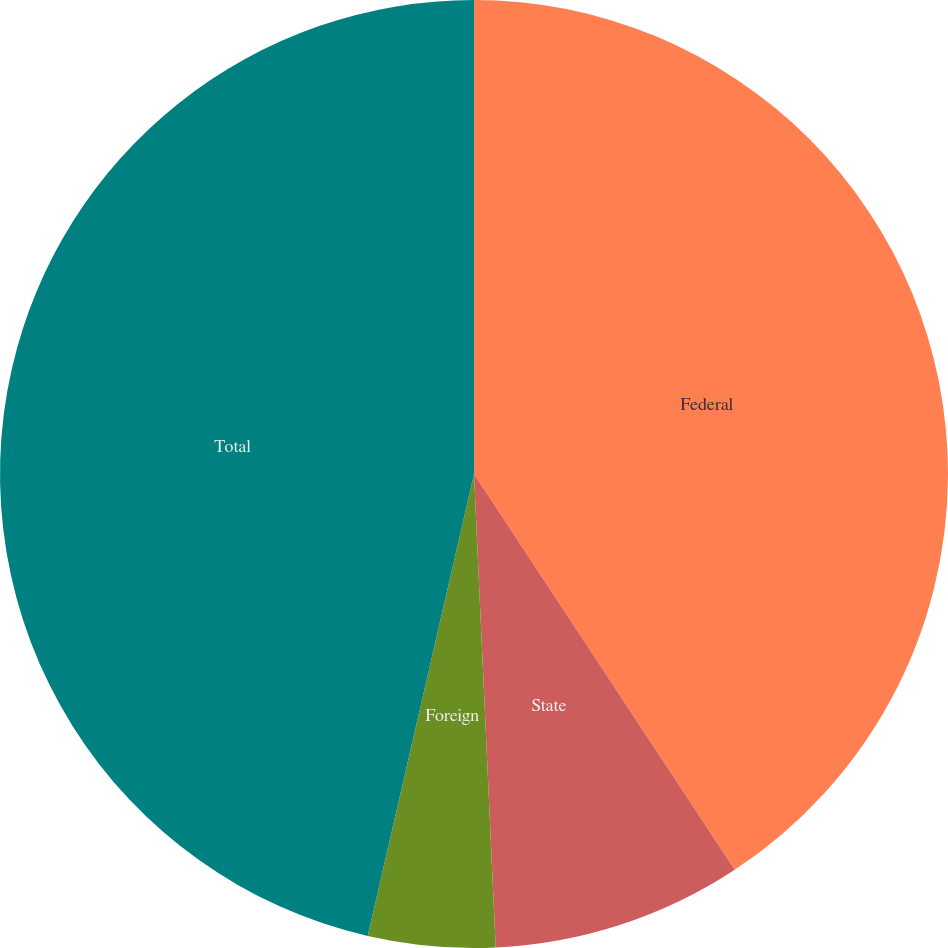Convert chart to OTSL. <chart><loc_0><loc_0><loc_500><loc_500><pie_chart><fcel>Federal<fcel>State<fcel>Foreign<fcel>Total<nl><fcel>40.73%<fcel>8.54%<fcel>4.33%<fcel>46.4%<nl></chart> 